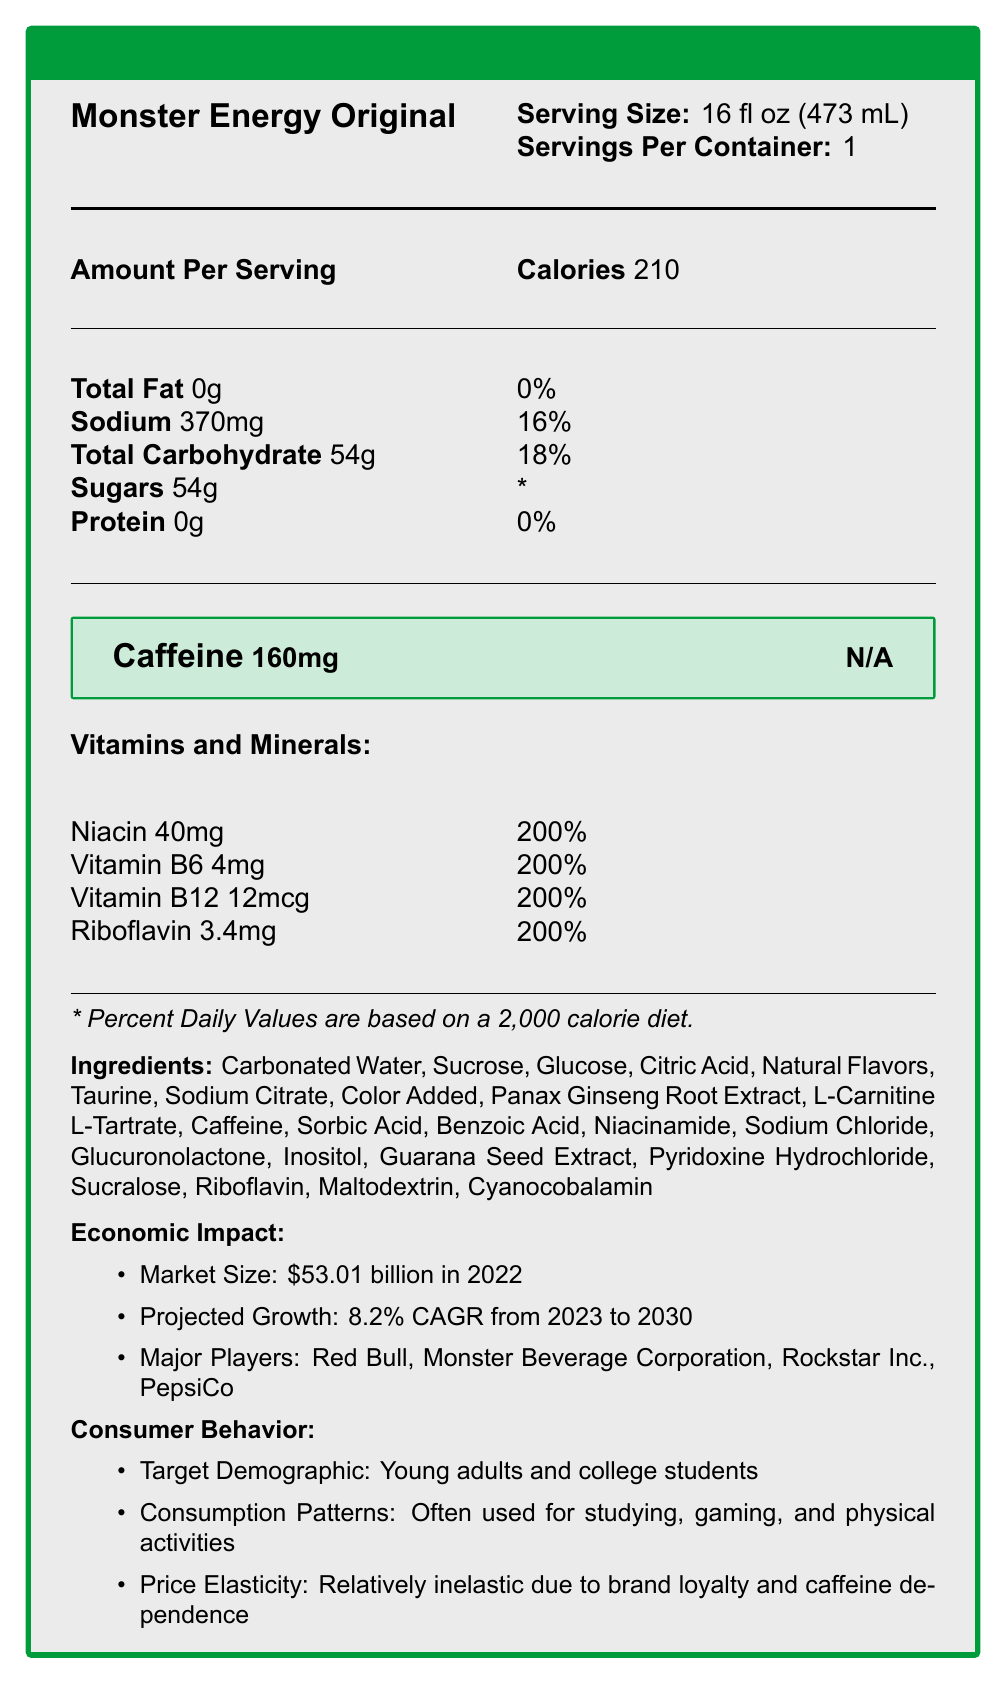What is the serving size of Monster Energy Original? The serving size is listed under the product name in the first column of the document.
Answer: 16 fl oz (473 mL) How many calories are in one serving? The calories per serving are provided under the "Amount Per Serving" section.
Answer: 210 What is the caffeine content in Monster Energy Original? The caffeine content is highlighted in a box with the label "Caffeine 160mg N/A".
Answer: 160mg How much sodium does one serving contain? Sodium content is listed under the nutrition facts with the corresponding amount of 370mg.
Answer: 370mg What percentage of the daily value of Vitamin B12 does this energy drink provide? The percentage of the daily value for Vitamin B12 is listed under the vitamins and minerals section.
Answer: 200% Which vitamin is present at the highest amount in terms of percent daily value? The document lists all the mentioned vitamins with a daily value of 200%.
Answer: All listed vitamins (Niacin, Vitamin B6, Vitamin B12, Riboflavin) are at 200% What are the potential health concerns associated with consuming Monster Energy Original? The health concerns section lists issues such as excessive caffeine intake leading to anxiety and insomnia, and high sugar content contributing to obesity and dental problems.
Answer: May lead to anxiety, insomnia, increased heart rate, obesity, and dental problems Who are the major players in the energy drink market? A. Red Bull B. Monster Beverage Corporation C. Rockstar Inc. D. PepsiCo E. All of the above The major players section lists Red Bull, Monster Beverage Corporation, Rockstar Inc., and PepsiCo as the major players in the market.
Answer: E What is the price elasticity of Monster Energy drinks? A. Highly elastic B. Relatively inelastic C. Perfectly inelastic The consumer behavior section describes the price elasticity as relatively inelastic due to brand loyalty and caffeine dependence.
Answer: B Does Monster Energy Original contain any proteins? The nutrition facts clearly states that the protein content is 0g.
Answer: No Is there any information provided about the market size of energy drinks? The economic impact section states that the market size was $53.01 billion in 2022.
Answer: Yes Summarize the main features of the nutrition facts and additional information provided about Monster Energy Original. This document provides comprehensive information about the nutritional content, economic impact, consumer behavior, health concerns, and regulatory issues associated with Monster Energy Original.
Answer: Monster Energy Original has a serving size of 16 fl oz, contains 210 calories, and provides significant amounts of caffeine (160mg) and vitamins (each at 200% daily value). It has negligible fat and protein, but a high carbohydrate and sugar content (54g). Additionally, the document touches on economic impact, consumer behavior, health concerns, and regulatory issues related to the product. What is the exact amount of caffeine in a 32 fl oz serving if the caffeine content is proportionate? The document only provides the caffeine content for a 16 fl oz serving, and it does not specify if the content scales proportionally for different serving sizes.
Answer: Cannot be determined 